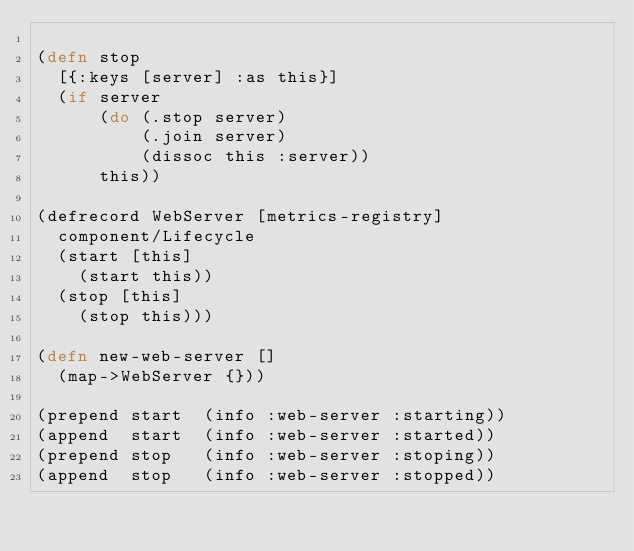Convert code to text. <code><loc_0><loc_0><loc_500><loc_500><_Clojure_>
(defn stop
  [{:keys [server] :as this}]
  (if server
      (do (.stop server)
          (.join server)
          (dissoc this :server))
      this))

(defrecord WebServer [metrics-registry]
  component/Lifecycle
  (start [this]
    (start this))
  (stop [this]
    (stop this)))

(defn new-web-server []
  (map->WebServer {}))

(prepend start  (info :web-server :starting))
(append  start  (info :web-server :started))
(prepend stop   (info :web-server :stoping))
(append  stop   (info :web-server :stopped))
</code> 